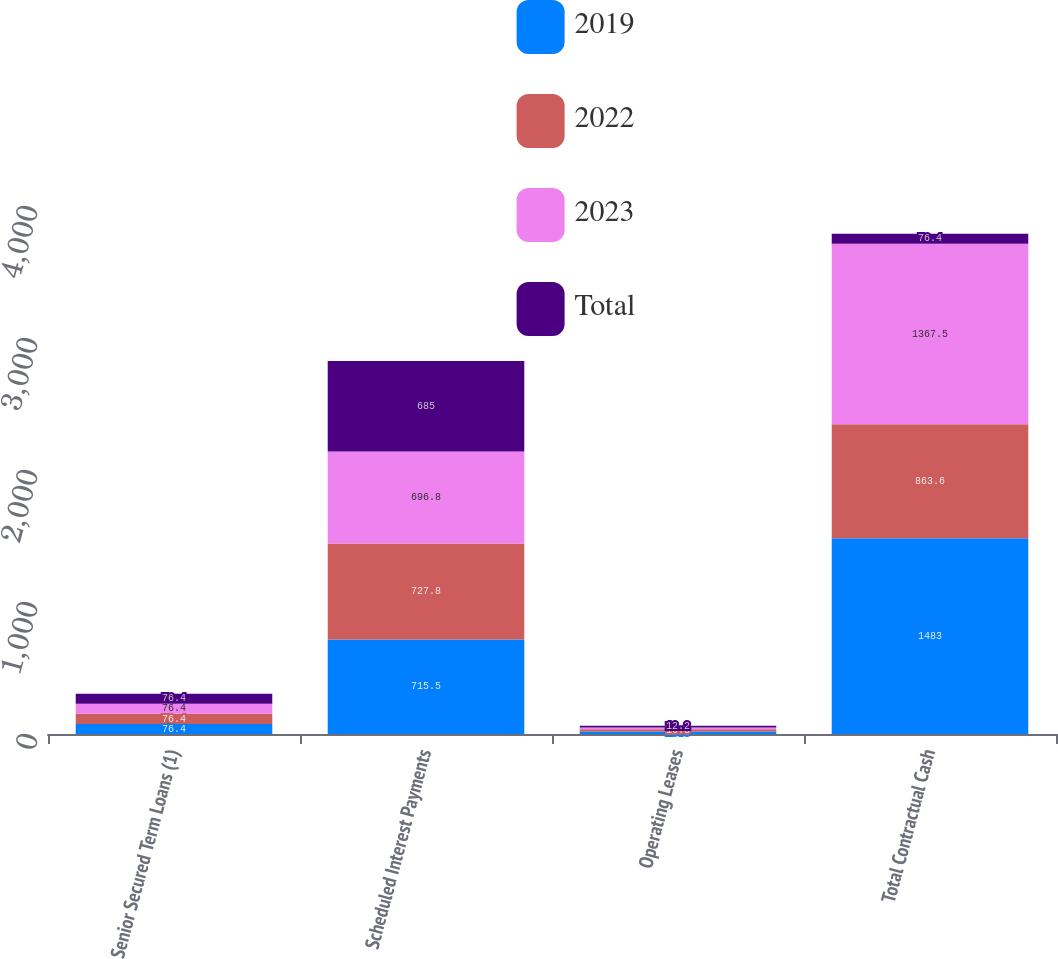Convert chart to OTSL. <chart><loc_0><loc_0><loc_500><loc_500><stacked_bar_chart><ecel><fcel>Senior Secured Term Loans (1)<fcel>Scheduled Interest Payments<fcel>Operating Leases<fcel>Total Contractual Cash<nl><fcel>2019<fcel>76.4<fcel>715.5<fcel>19.3<fcel>1483<nl><fcel>2022<fcel>76.4<fcel>727.8<fcel>16.3<fcel>863.6<nl><fcel>2023<fcel>76.4<fcel>696.8<fcel>13.9<fcel>1367.5<nl><fcel>Total<fcel>76.4<fcel>685<fcel>12.2<fcel>76.4<nl></chart> 